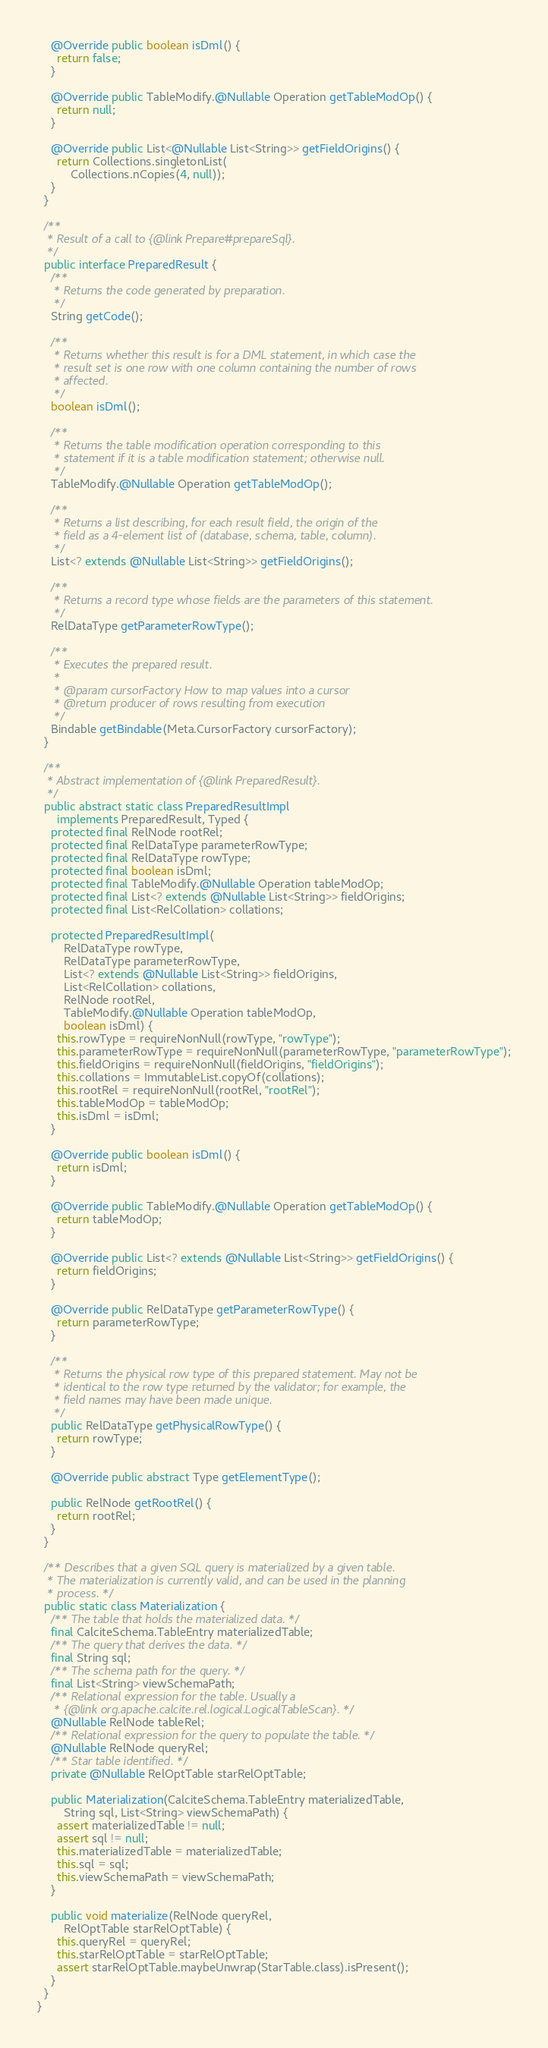Convert code to text. <code><loc_0><loc_0><loc_500><loc_500><_Java_>
    @Override public boolean isDml() {
      return false;
    }

    @Override public TableModify.@Nullable Operation getTableModOp() {
      return null;
    }

    @Override public List<@Nullable List<String>> getFieldOrigins() {
      return Collections.singletonList(
          Collections.nCopies(4, null));
    }
  }

  /**
   * Result of a call to {@link Prepare#prepareSql}.
   */
  public interface PreparedResult {
    /**
     * Returns the code generated by preparation.
     */
    String getCode();

    /**
     * Returns whether this result is for a DML statement, in which case the
     * result set is one row with one column containing the number of rows
     * affected.
     */
    boolean isDml();

    /**
     * Returns the table modification operation corresponding to this
     * statement if it is a table modification statement; otherwise null.
     */
    TableModify.@Nullable Operation getTableModOp();

    /**
     * Returns a list describing, for each result field, the origin of the
     * field as a 4-element list of (database, schema, table, column).
     */
    List<? extends @Nullable List<String>> getFieldOrigins();

    /**
     * Returns a record type whose fields are the parameters of this statement.
     */
    RelDataType getParameterRowType();

    /**
     * Executes the prepared result.
     *
     * @param cursorFactory How to map values into a cursor
     * @return producer of rows resulting from execution
     */
    Bindable getBindable(Meta.CursorFactory cursorFactory);
  }

  /**
   * Abstract implementation of {@link PreparedResult}.
   */
  public abstract static class PreparedResultImpl
      implements PreparedResult, Typed {
    protected final RelNode rootRel;
    protected final RelDataType parameterRowType;
    protected final RelDataType rowType;
    protected final boolean isDml;
    protected final TableModify.@Nullable Operation tableModOp;
    protected final List<? extends @Nullable List<String>> fieldOrigins;
    protected final List<RelCollation> collations;

    protected PreparedResultImpl(
        RelDataType rowType,
        RelDataType parameterRowType,
        List<? extends @Nullable List<String>> fieldOrigins,
        List<RelCollation> collations,
        RelNode rootRel,
        TableModify.@Nullable Operation tableModOp,
        boolean isDml) {
      this.rowType = requireNonNull(rowType, "rowType");
      this.parameterRowType = requireNonNull(parameterRowType, "parameterRowType");
      this.fieldOrigins = requireNonNull(fieldOrigins, "fieldOrigins");
      this.collations = ImmutableList.copyOf(collations);
      this.rootRel = requireNonNull(rootRel, "rootRel");
      this.tableModOp = tableModOp;
      this.isDml = isDml;
    }

    @Override public boolean isDml() {
      return isDml;
    }

    @Override public TableModify.@Nullable Operation getTableModOp() {
      return tableModOp;
    }

    @Override public List<? extends @Nullable List<String>> getFieldOrigins() {
      return fieldOrigins;
    }

    @Override public RelDataType getParameterRowType() {
      return parameterRowType;
    }

    /**
     * Returns the physical row type of this prepared statement. May not be
     * identical to the row type returned by the validator; for example, the
     * field names may have been made unique.
     */
    public RelDataType getPhysicalRowType() {
      return rowType;
    }

    @Override public abstract Type getElementType();

    public RelNode getRootRel() {
      return rootRel;
    }
  }

  /** Describes that a given SQL query is materialized by a given table.
   * The materialization is currently valid, and can be used in the planning
   * process. */
  public static class Materialization {
    /** The table that holds the materialized data. */
    final CalciteSchema.TableEntry materializedTable;
    /** The query that derives the data. */
    final String sql;
    /** The schema path for the query. */
    final List<String> viewSchemaPath;
    /** Relational expression for the table. Usually a
     * {@link org.apache.calcite.rel.logical.LogicalTableScan}. */
    @Nullable RelNode tableRel;
    /** Relational expression for the query to populate the table. */
    @Nullable RelNode queryRel;
    /** Star table identified. */
    private @Nullable RelOptTable starRelOptTable;

    public Materialization(CalciteSchema.TableEntry materializedTable,
        String sql, List<String> viewSchemaPath) {
      assert materializedTable != null;
      assert sql != null;
      this.materializedTable = materializedTable;
      this.sql = sql;
      this.viewSchemaPath = viewSchemaPath;
    }

    public void materialize(RelNode queryRel,
        RelOptTable starRelOptTable) {
      this.queryRel = queryRel;
      this.starRelOptTable = starRelOptTable;
      assert starRelOptTable.maybeUnwrap(StarTable.class).isPresent();
    }
  }
}
</code> 